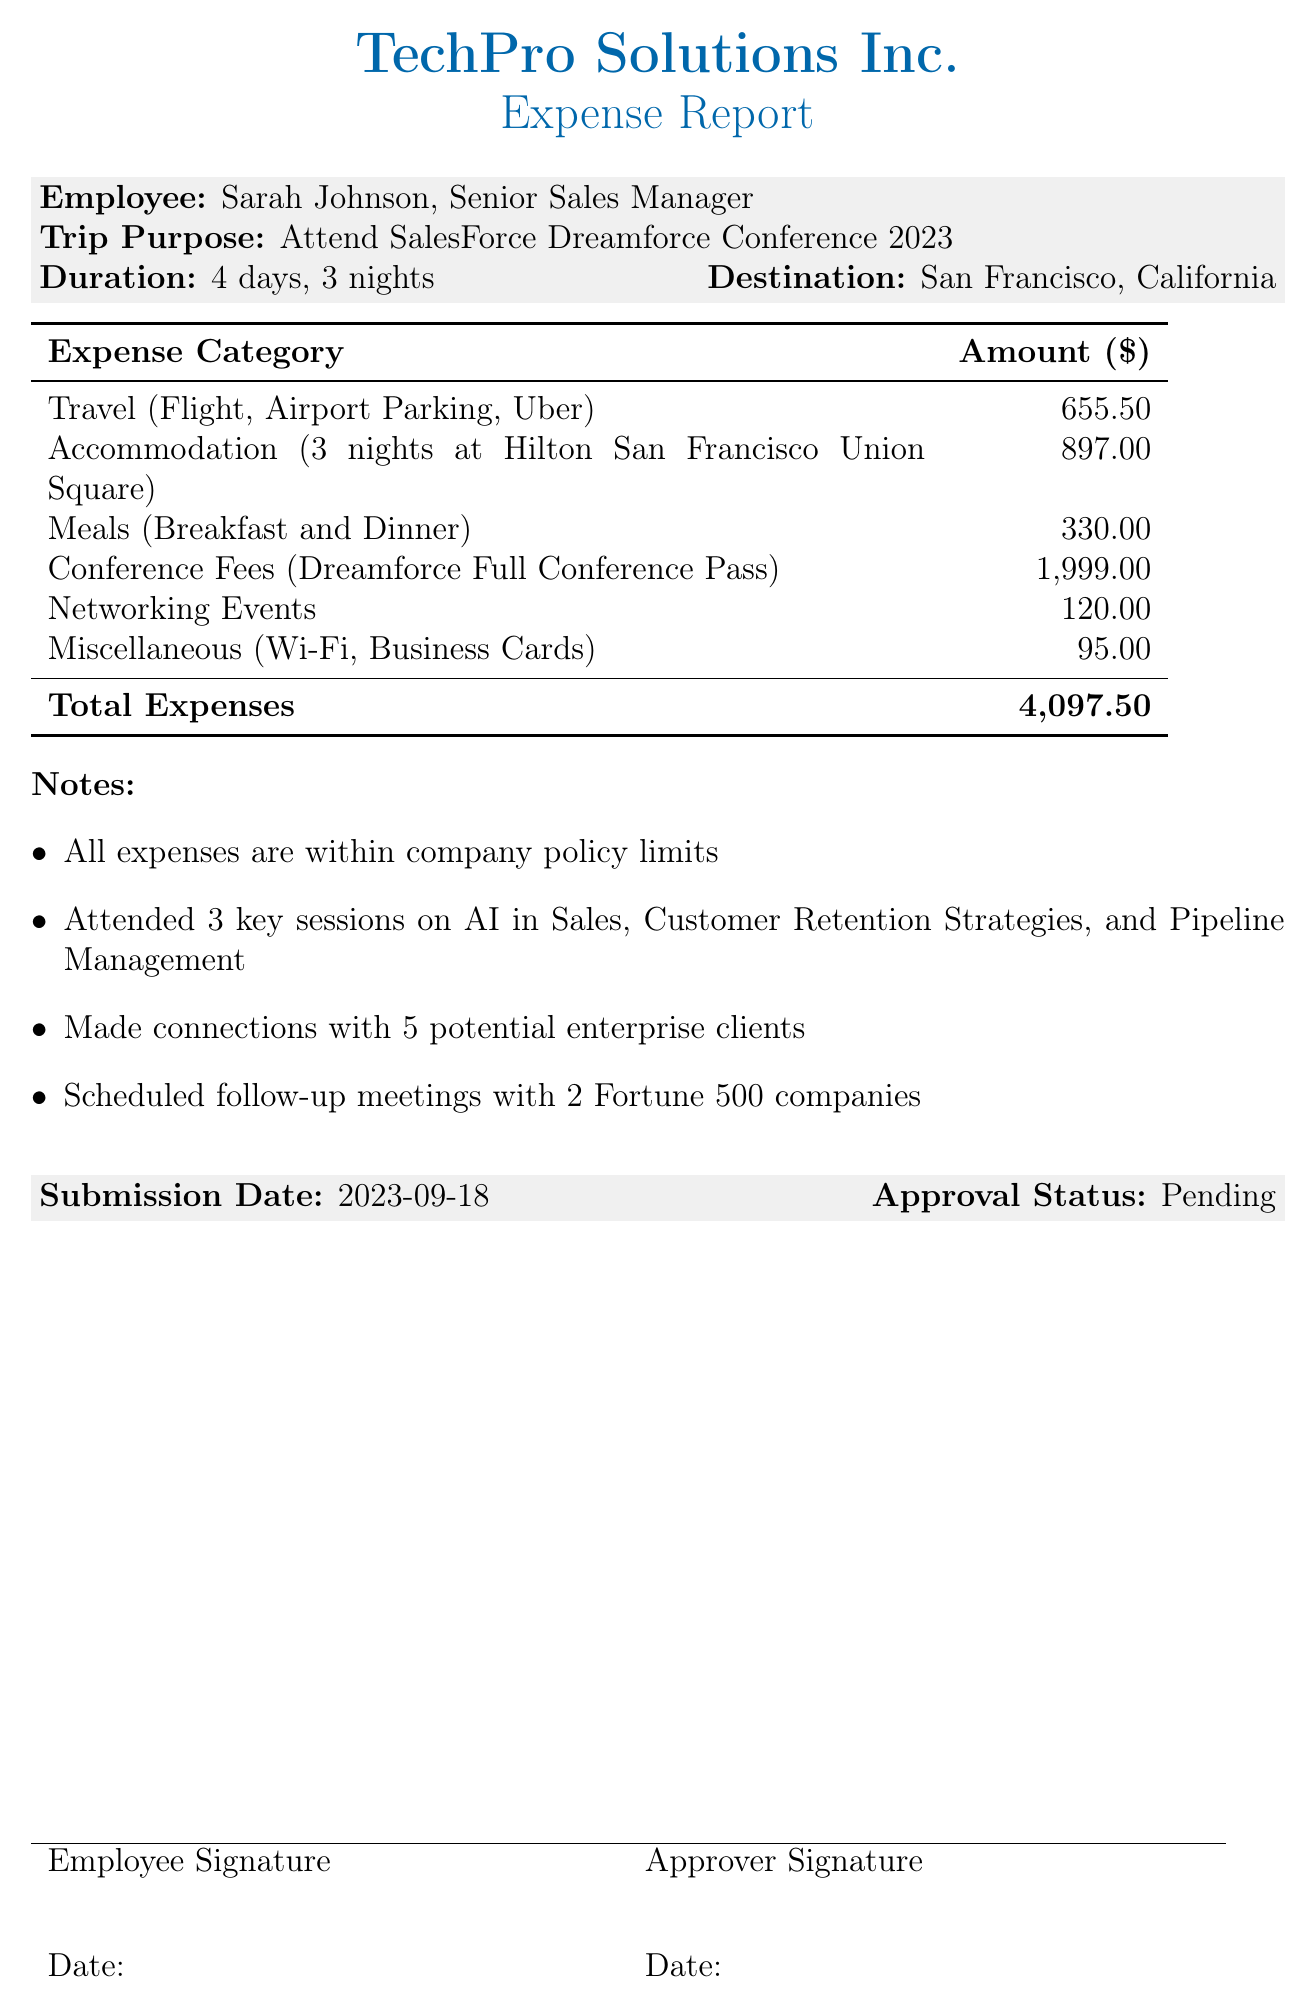What is the purpose of the trip? The purpose of the trip is stated as attending the SalesForce Dreamforce Conference 2023.
Answer: Attend SalesForce Dreamforce Conference 2023 Who is the employee making the expense report? The document lists Sarah Johnson as the employee making the report.
Answer: Sarah Johnson What is the total amount of expenses? The total expenses are explicitly stated at the bottom of the document.
Answer: 4097.50 How many nights did the employee stay at the hotel? The document specifies that the accommodation is for 3 nights.
Answer: 3 nights What was the amount spent on the Dreamforce Full Conference Pass? The amount for the conference pass is detailed in the Conference Fees section.
Answer: 1999.00 Which city was the conference held in? The destination for the trip is mentioned in the document.
Answer: San Francisco, California How many potential enterprise clients were connected with during the trip? The notes section indicates the number of connections made during the trip.
Answer: 5 potential enterprise clients What was the approval status of the expense report? The document includes the current status of the report.
Answer: Pending What was the submission date of the expense report? The date on which the report was submitted is specified in the document.
Answer: 2023-09-18 